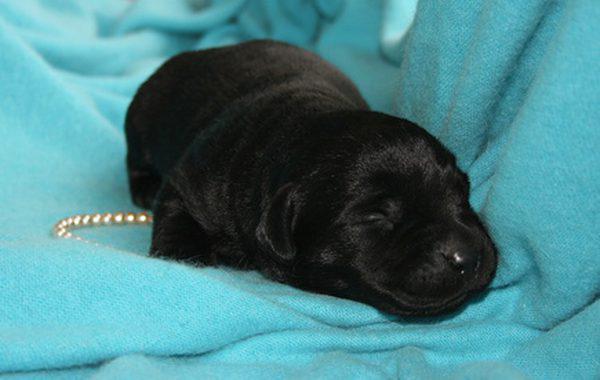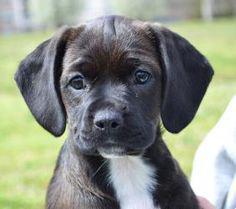The first image is the image on the left, the second image is the image on the right. Examine the images to the left and right. Is the description "One image shows exactly three dogs, each a different color." accurate? Answer yes or no. No. 